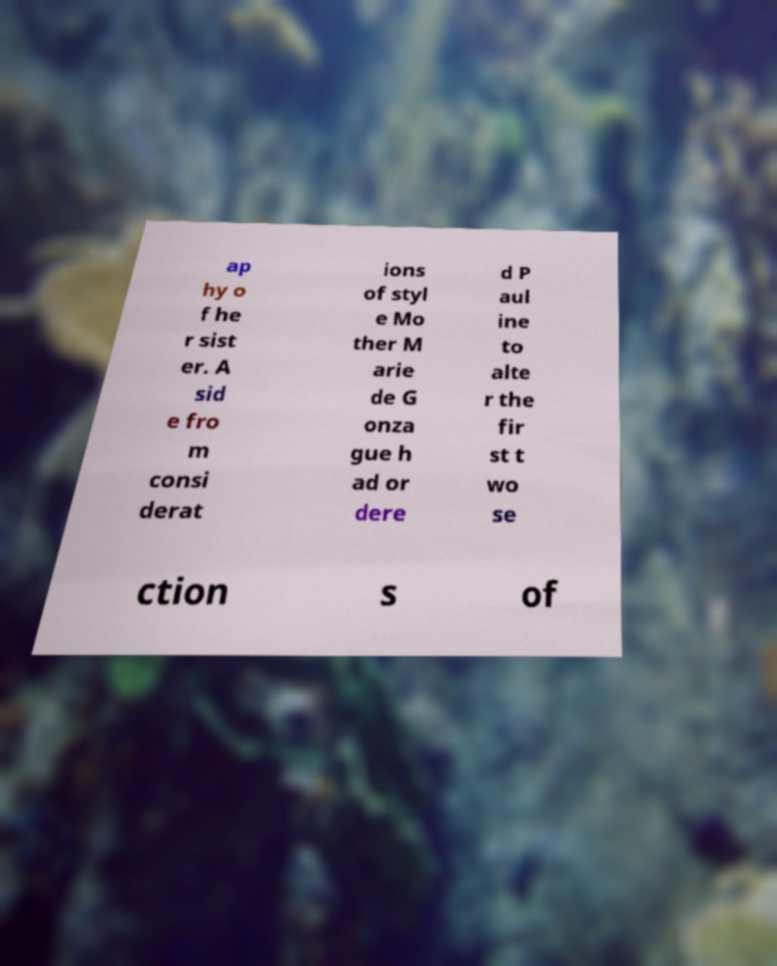Could you extract and type out the text from this image? ap hy o f he r sist er. A sid e fro m consi derat ions of styl e Mo ther M arie de G onza gue h ad or dere d P aul ine to alte r the fir st t wo se ction s of 